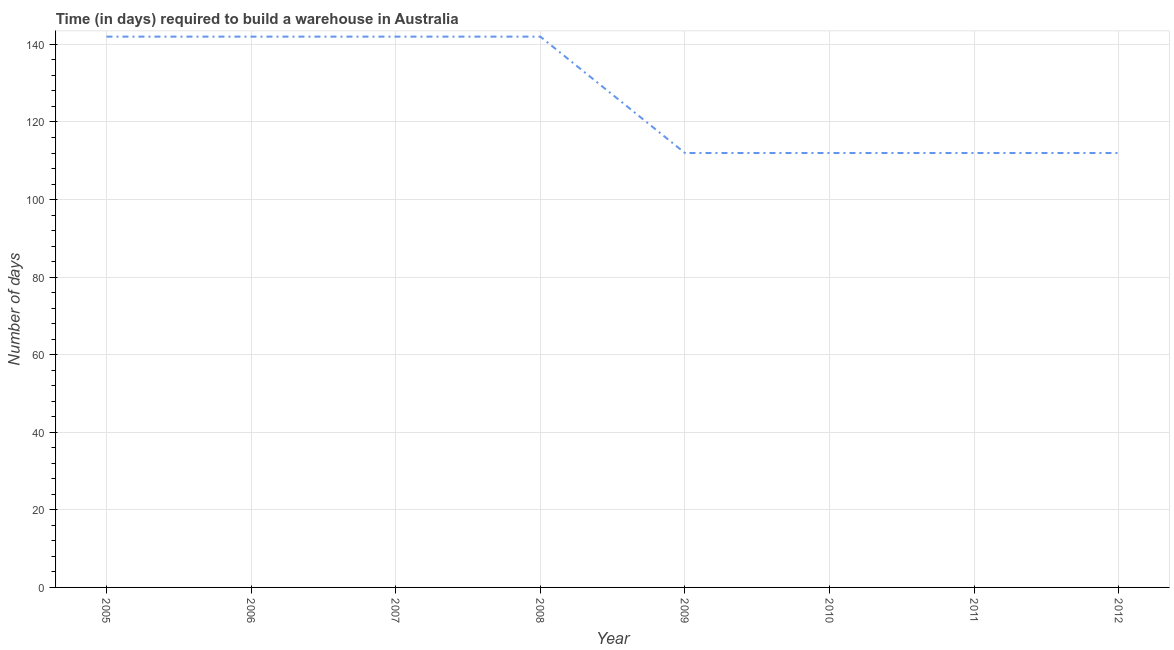What is the time required to build a warehouse in 2005?
Ensure brevity in your answer.  142. Across all years, what is the maximum time required to build a warehouse?
Give a very brief answer. 142. Across all years, what is the minimum time required to build a warehouse?
Give a very brief answer. 112. What is the sum of the time required to build a warehouse?
Offer a very short reply. 1016. What is the average time required to build a warehouse per year?
Offer a very short reply. 127. What is the median time required to build a warehouse?
Offer a very short reply. 127. What is the ratio of the time required to build a warehouse in 2009 to that in 2010?
Your answer should be very brief. 1. Is the time required to build a warehouse in 2010 less than that in 2012?
Offer a very short reply. No. Is the sum of the time required to build a warehouse in 2010 and 2012 greater than the maximum time required to build a warehouse across all years?
Your response must be concise. Yes. What is the difference between the highest and the lowest time required to build a warehouse?
Your answer should be compact. 30. In how many years, is the time required to build a warehouse greater than the average time required to build a warehouse taken over all years?
Ensure brevity in your answer.  4. How many lines are there?
Provide a short and direct response. 1. Are the values on the major ticks of Y-axis written in scientific E-notation?
Offer a terse response. No. Does the graph contain any zero values?
Offer a very short reply. No. Does the graph contain grids?
Ensure brevity in your answer.  Yes. What is the title of the graph?
Keep it short and to the point. Time (in days) required to build a warehouse in Australia. What is the label or title of the X-axis?
Your answer should be very brief. Year. What is the label or title of the Y-axis?
Your response must be concise. Number of days. What is the Number of days in 2005?
Your response must be concise. 142. What is the Number of days in 2006?
Your answer should be very brief. 142. What is the Number of days of 2007?
Your answer should be compact. 142. What is the Number of days of 2008?
Keep it short and to the point. 142. What is the Number of days in 2009?
Ensure brevity in your answer.  112. What is the Number of days in 2010?
Provide a succinct answer. 112. What is the Number of days of 2011?
Make the answer very short. 112. What is the Number of days of 2012?
Ensure brevity in your answer.  112. What is the difference between the Number of days in 2005 and 2006?
Keep it short and to the point. 0. What is the difference between the Number of days in 2005 and 2007?
Ensure brevity in your answer.  0. What is the difference between the Number of days in 2005 and 2008?
Your answer should be very brief. 0. What is the difference between the Number of days in 2005 and 2011?
Your answer should be very brief. 30. What is the difference between the Number of days in 2005 and 2012?
Make the answer very short. 30. What is the difference between the Number of days in 2006 and 2009?
Keep it short and to the point. 30. What is the difference between the Number of days in 2006 and 2010?
Keep it short and to the point. 30. What is the difference between the Number of days in 2007 and 2008?
Keep it short and to the point. 0. What is the difference between the Number of days in 2007 and 2012?
Your answer should be compact. 30. What is the difference between the Number of days in 2008 and 2009?
Your answer should be very brief. 30. What is the difference between the Number of days in 2009 and 2010?
Offer a very short reply. 0. What is the difference between the Number of days in 2009 and 2011?
Your answer should be very brief. 0. What is the difference between the Number of days in 2010 and 2011?
Your response must be concise. 0. What is the difference between the Number of days in 2010 and 2012?
Keep it short and to the point. 0. What is the difference between the Number of days in 2011 and 2012?
Offer a terse response. 0. What is the ratio of the Number of days in 2005 to that in 2006?
Your response must be concise. 1. What is the ratio of the Number of days in 2005 to that in 2008?
Your response must be concise. 1. What is the ratio of the Number of days in 2005 to that in 2009?
Provide a short and direct response. 1.27. What is the ratio of the Number of days in 2005 to that in 2010?
Provide a short and direct response. 1.27. What is the ratio of the Number of days in 2005 to that in 2011?
Ensure brevity in your answer.  1.27. What is the ratio of the Number of days in 2005 to that in 2012?
Ensure brevity in your answer.  1.27. What is the ratio of the Number of days in 2006 to that in 2008?
Make the answer very short. 1. What is the ratio of the Number of days in 2006 to that in 2009?
Provide a short and direct response. 1.27. What is the ratio of the Number of days in 2006 to that in 2010?
Your answer should be compact. 1.27. What is the ratio of the Number of days in 2006 to that in 2011?
Give a very brief answer. 1.27. What is the ratio of the Number of days in 2006 to that in 2012?
Give a very brief answer. 1.27. What is the ratio of the Number of days in 2007 to that in 2009?
Give a very brief answer. 1.27. What is the ratio of the Number of days in 2007 to that in 2010?
Give a very brief answer. 1.27. What is the ratio of the Number of days in 2007 to that in 2011?
Your response must be concise. 1.27. What is the ratio of the Number of days in 2007 to that in 2012?
Keep it short and to the point. 1.27. What is the ratio of the Number of days in 2008 to that in 2009?
Make the answer very short. 1.27. What is the ratio of the Number of days in 2008 to that in 2010?
Offer a terse response. 1.27. What is the ratio of the Number of days in 2008 to that in 2011?
Keep it short and to the point. 1.27. What is the ratio of the Number of days in 2008 to that in 2012?
Give a very brief answer. 1.27. What is the ratio of the Number of days in 2009 to that in 2011?
Provide a succinct answer. 1. What is the ratio of the Number of days in 2010 to that in 2011?
Provide a short and direct response. 1. What is the ratio of the Number of days in 2010 to that in 2012?
Offer a terse response. 1. 